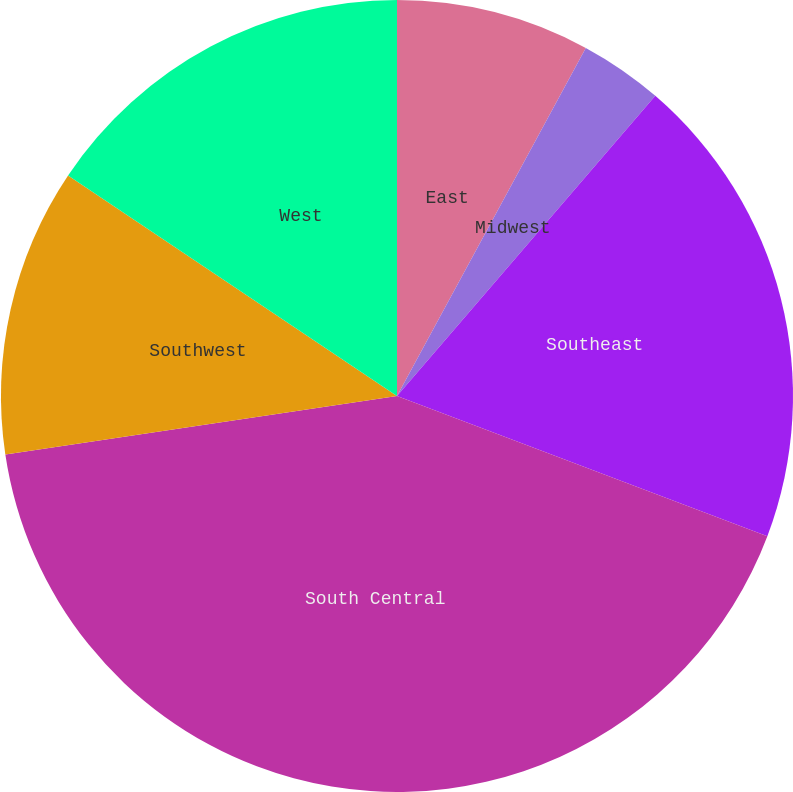<chart> <loc_0><loc_0><loc_500><loc_500><pie_chart><fcel>East<fcel>Midwest<fcel>Southeast<fcel>South Central<fcel>Southwest<fcel>West<nl><fcel>7.91%<fcel>3.4%<fcel>19.45%<fcel>41.88%<fcel>11.76%<fcel>15.6%<nl></chart> 